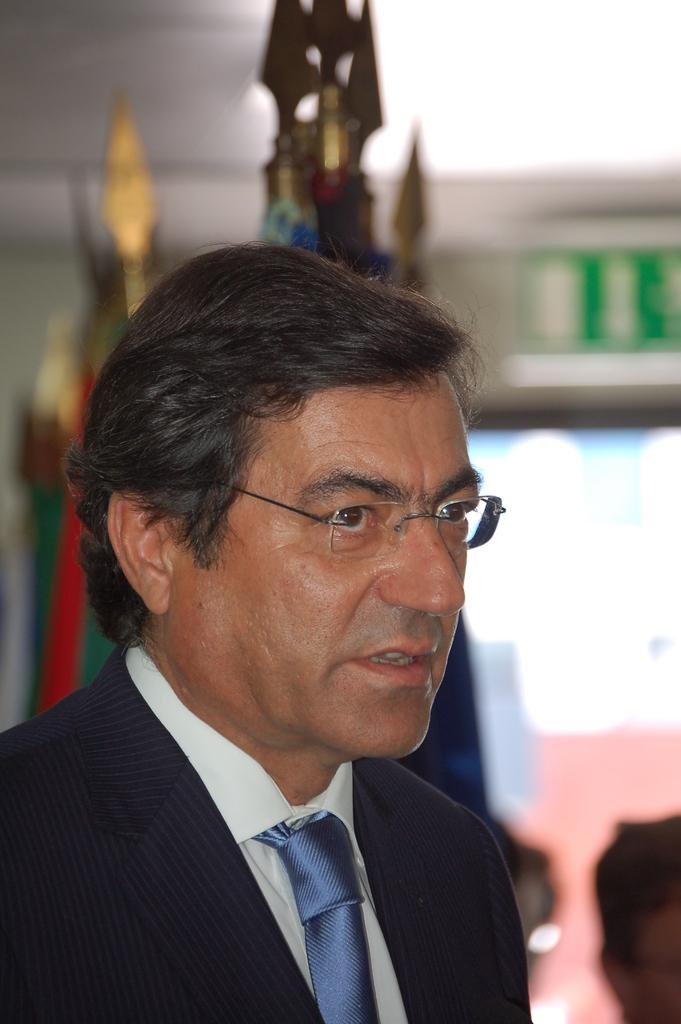Who is the main subject in the image? There is a man in the image. Can you describe the other person in the image? There is another person in the bottom right of the image. What can be seen behind the man? There are objects behind the man. How would you describe the background of the image? The background of the image is blurred. What type of stitch is being used to sew the fish in the image? There is no stitch or fish present in the image. 